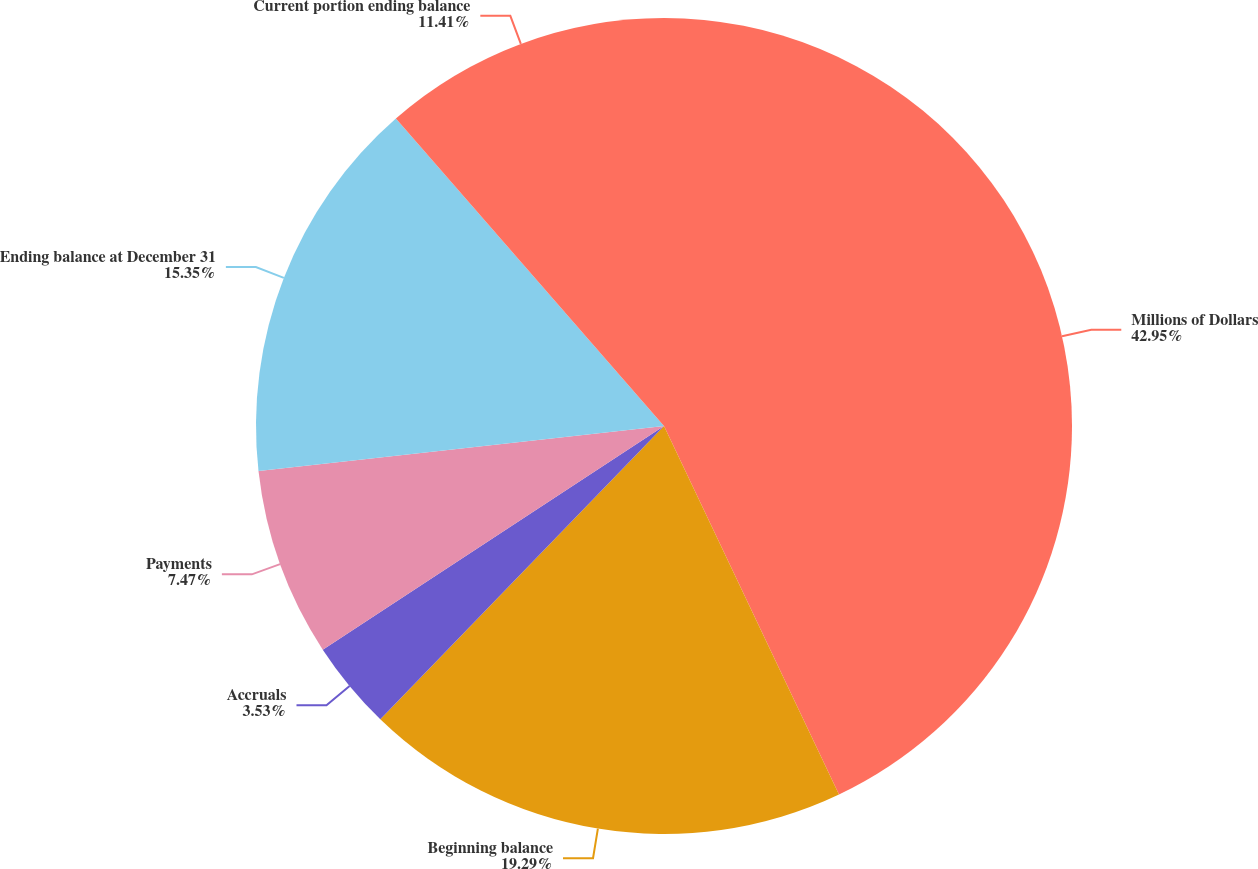Convert chart. <chart><loc_0><loc_0><loc_500><loc_500><pie_chart><fcel>Millions of Dollars<fcel>Beginning balance<fcel>Accruals<fcel>Payments<fcel>Ending balance at December 31<fcel>Current portion ending balance<nl><fcel>42.94%<fcel>19.29%<fcel>3.53%<fcel>7.47%<fcel>15.35%<fcel>11.41%<nl></chart> 